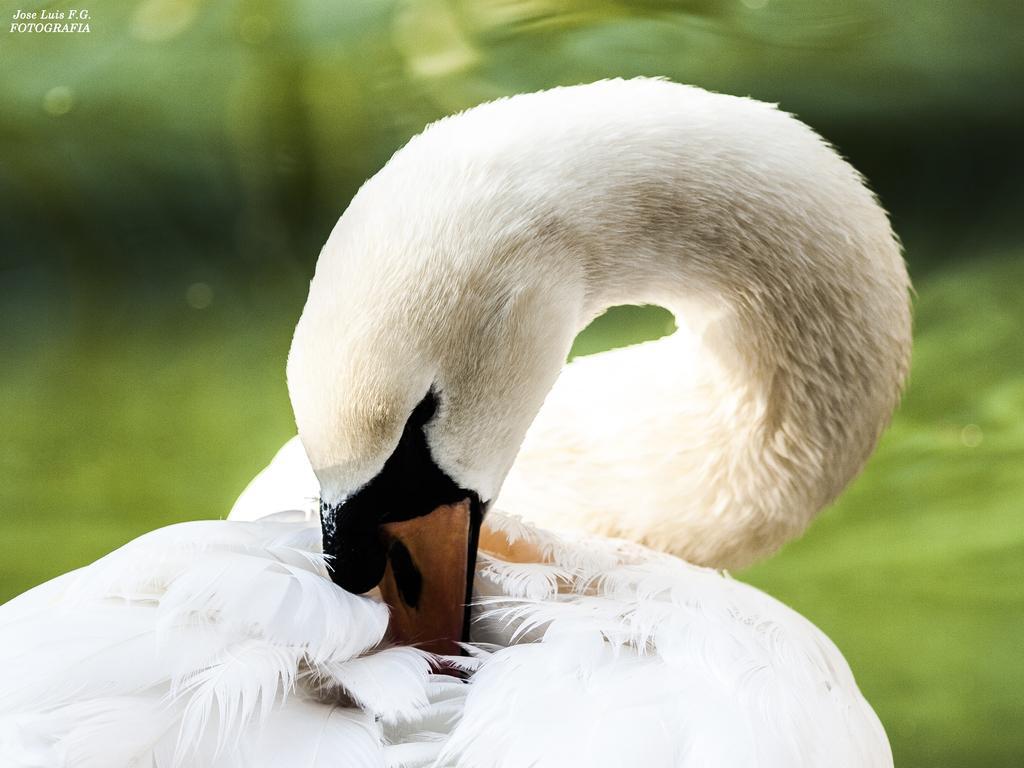How would you summarize this image in a sentence or two? In the picture I can see a white color bird. The background of the image is blurred. On the top left corner of the image I can see a watermark. 